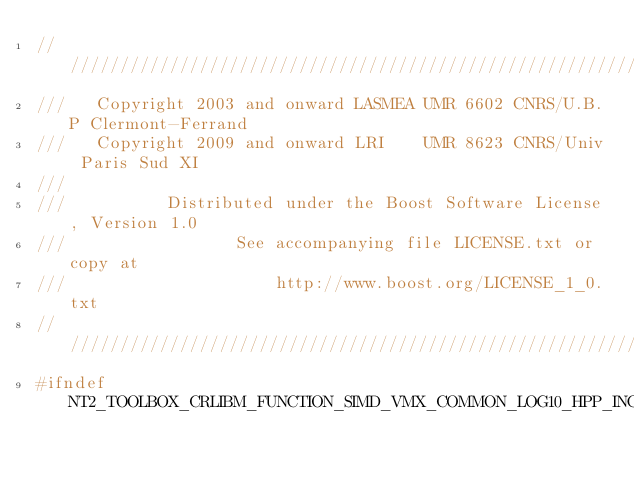<code> <loc_0><loc_0><loc_500><loc_500><_C++_>//////////////////////////////////////////////////////////////////////////////
///   Copyright 2003 and onward LASMEA UMR 6602 CNRS/U.B.P Clermont-Ferrand
///   Copyright 2009 and onward LRI    UMR 8623 CNRS/Univ Paris Sud XI
///
///          Distributed under the Boost Software License, Version 1.0
///                 See accompanying file LICENSE.txt or copy at
///                     http://www.boost.org/LICENSE_1_0.txt
//////////////////////////////////////////////////////////////////////////////
#ifndef NT2_TOOLBOX_CRLIBM_FUNCTION_SIMD_VMX_COMMON_LOG10_HPP_INCLUDED</code> 